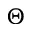<formula> <loc_0><loc_0><loc_500><loc_500>\Theta</formula> 